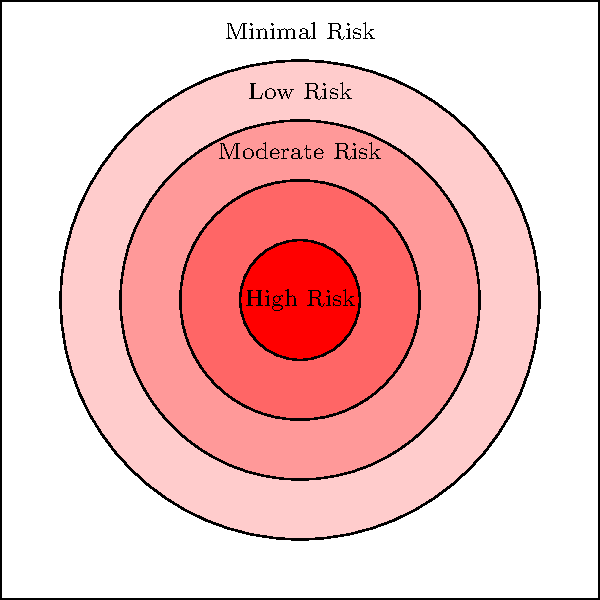Based on the color-coded security risk map of an urban area, what percentage of the total area is classified as "High Risk" (the darkest red zone)? To determine the percentage of the total area classified as "High Risk", we need to follow these steps:

1. Identify the total area of the map:
   The map is a square with side length 5 units (from -2.5 to 2.5 on both axes).
   Total area = $5 \times 5 = 25$ square units

2. Identify the area of the "High Risk" zone:
   The "High Risk" zone is a circle with radius 0.5 units.
   Area of High Risk zone = $\pi r^2 = \pi \times (0.5)^2 = 0.25\pi$ square units

3. Calculate the percentage:
   Percentage = (Area of High Risk zone / Total area) $\times 100\%$
   $= (0.25\pi / 25) \times 100\%$
   $= 0.01\pi \times 100\%$
   $\approx 3.14\%$

4. Round to the nearest whole number:
   $3.14\% \approx 3\%$

Therefore, approximately 3% of the total area is classified as "High Risk".
Answer: 3% 